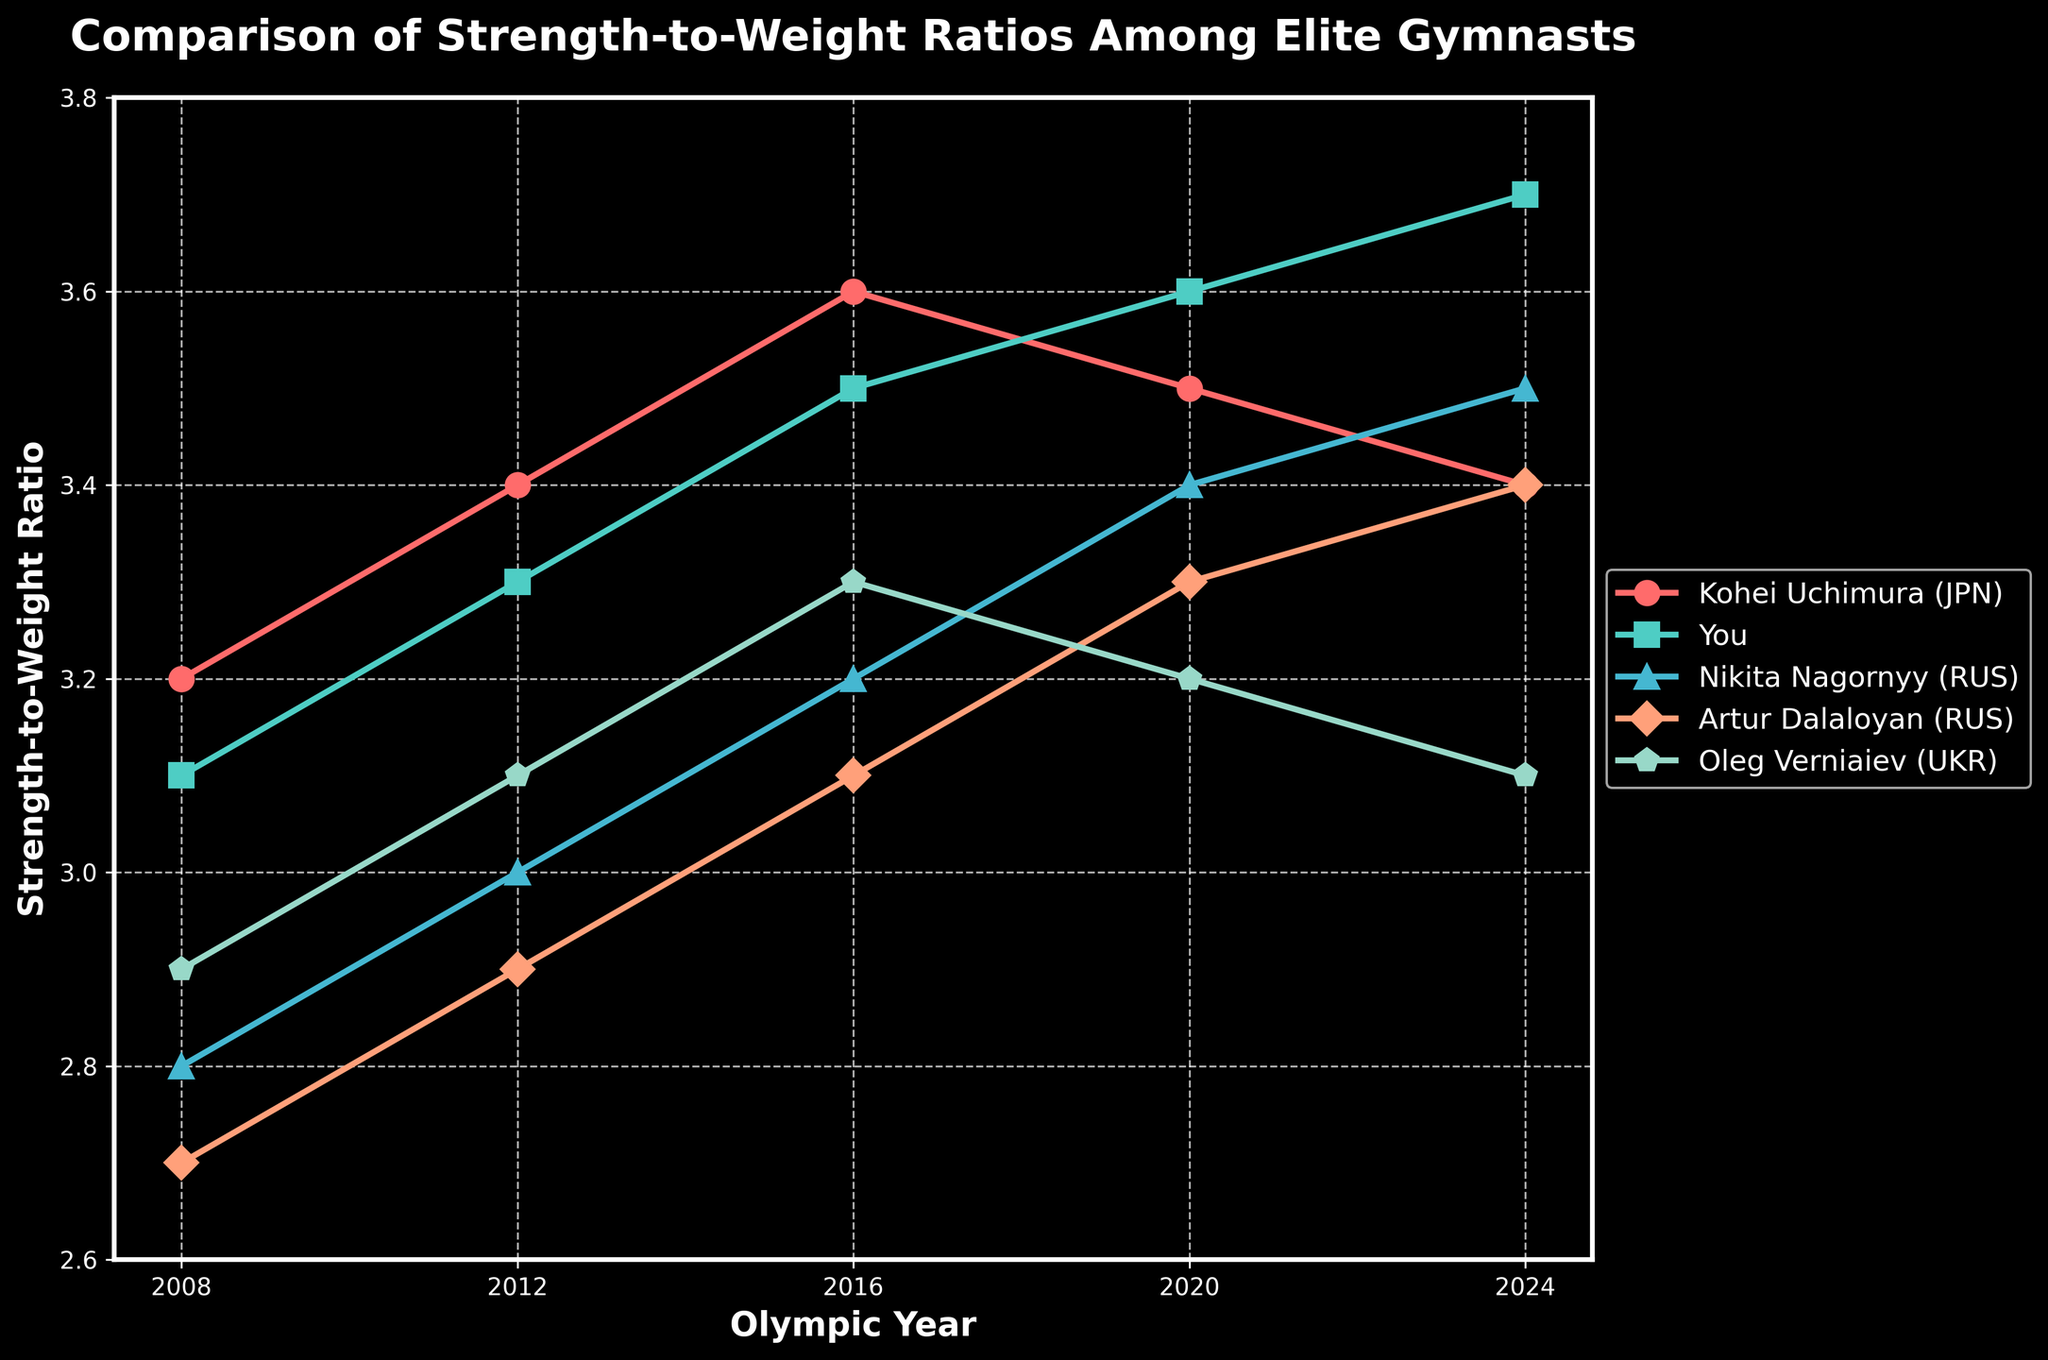Who had the highest strength-to-weight ratio in 2020? Look at the points on the chart for 2020, then identify the highest point and the corresponding gymnast.
Answer: You Who had a steady increase in strength-to-weight ratio from 2008 to 2024? Check the lines from 2008 to 2024 and see which one shows a consistent upward trend.
Answer: You What is the difference in strength-to-weight ratio between Kohei Uchimura and Artur Dalaloyan in 2024? Find the 2024 values for Kohei Uchimura and Artur Dalaloyan, then subtract the smaller from the larger.
Answer: 0 Which two gymnasts had the closest strength-to-weight ratio in 2016, and what was the difference? Look at the 2016 values and compare each pair, then identify the pair with the smallest difference and calculate the difference.
Answer: Artur Dalaloyan and Oleg Verniaiev, 0.2 What is the average strength-to-weight ratio of Oleg Verniaiev over all the years shown? Sum up Oleg Verniaiev's strength-to-weight ratios for all the years and divide by the number of years.
Answer: 3.1 Between Kohei Uchimura and Nikita Nagornyy, who had more fluctuations in their strength-to-weight ratio over the years? Look at the trends for both gymnasts and see which one has a more irregular line with more ups and downs.
Answer: Kohei Uchimura In which year did all gymnasts except one see an increase in their strength-to-weight ratio compared to the previous Olympic cycle? Compare the values year by year and identify a year where four out of five gymnasts increased their values.
Answer: 2020 How much did your own strength-to-weight ratio improve from 2008 to 2024? Subtract the 2008 value from the 2024 value for yourself.
Answer: 0.6 